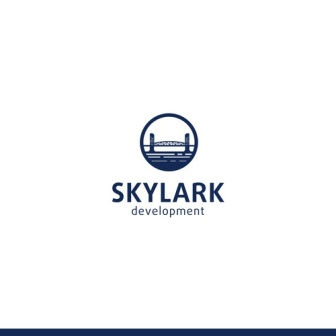What emotions or messages does this logo convey? The 'Skylark Development' logo conveys a sense of trust, professionalism, and forward-thinking. The clean and modern design elements, such as the stylized skyline and the use of blue, evoke feelings of reliability and stability. The presence of the bridge within the logo suggests connectivity and progress, hinting at the company's role in bridging communities or creating new pathways within urban landscapes. Overall, the logo communicates a message of innovation, growth, and dependability. 